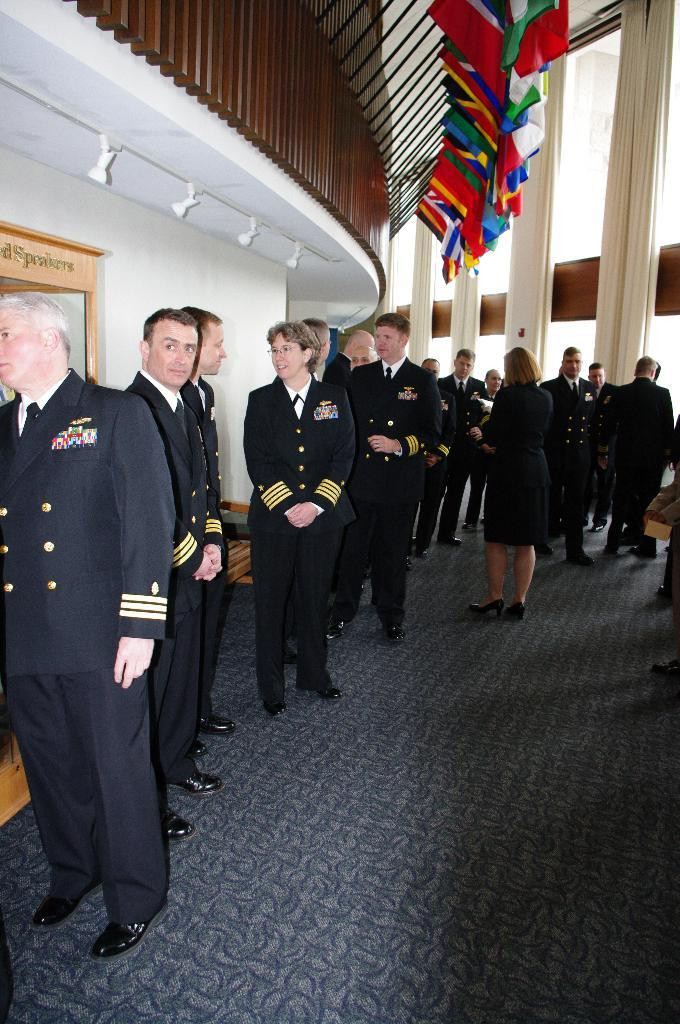What can be seen in the image? There are people standing in the image. What is the surface that the people are standing on? There is a floor visible in the image. What can be seen in the background of the image? There are flags, pillars, a railing, and a wall in the background of the image. What type of disease is affecting the eyes of the people in the image? There is no indication of any disease affecting the eyes of the people in the image. How much sugar is present in the image? There is no sugar visible in the image. 